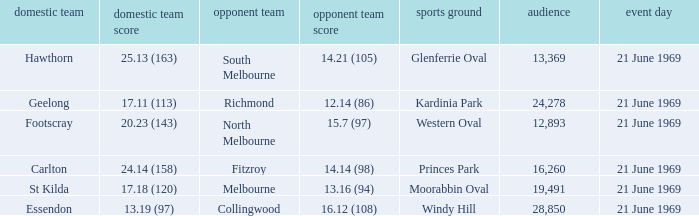When did an away team score 15.7 (97)? 21 June 1969. 